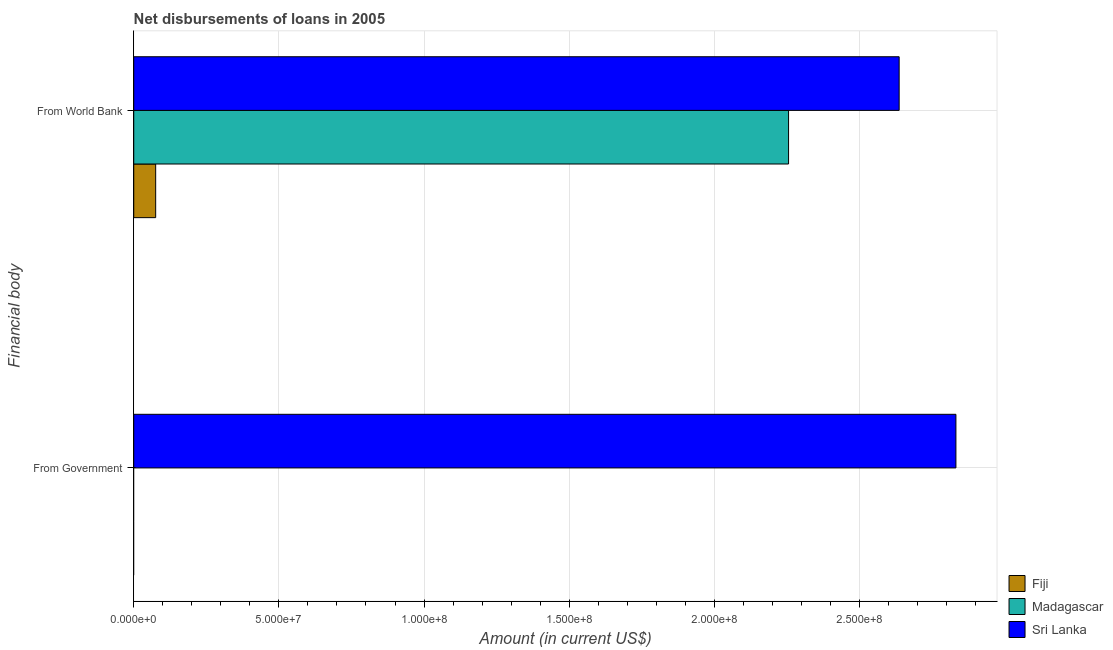Are the number of bars per tick equal to the number of legend labels?
Your response must be concise. No. What is the label of the 1st group of bars from the top?
Offer a terse response. From World Bank. What is the net disbursements of loan from world bank in Fiji?
Make the answer very short. 7.55e+06. Across all countries, what is the maximum net disbursements of loan from government?
Offer a terse response. 2.83e+08. In which country was the net disbursements of loan from government maximum?
Provide a succinct answer. Sri Lanka. What is the total net disbursements of loan from world bank in the graph?
Offer a terse response. 4.97e+08. What is the difference between the net disbursements of loan from world bank in Sri Lanka and that in Fiji?
Give a very brief answer. 2.56e+08. What is the difference between the net disbursements of loan from government in Sri Lanka and the net disbursements of loan from world bank in Fiji?
Offer a terse response. 2.76e+08. What is the average net disbursements of loan from government per country?
Your response must be concise. 9.44e+07. What is the difference between the net disbursements of loan from government and net disbursements of loan from world bank in Sri Lanka?
Your response must be concise. 1.96e+07. In how many countries, is the net disbursements of loan from government greater than 210000000 US$?
Provide a succinct answer. 1. What is the ratio of the net disbursements of loan from world bank in Sri Lanka to that in Fiji?
Offer a very short reply. 34.91. How many bars are there?
Provide a succinct answer. 4. Are all the bars in the graph horizontal?
Provide a short and direct response. Yes. What is the difference between two consecutive major ticks on the X-axis?
Make the answer very short. 5.00e+07. Does the graph contain any zero values?
Keep it short and to the point. Yes. Does the graph contain grids?
Your answer should be very brief. Yes. Where does the legend appear in the graph?
Your answer should be compact. Bottom right. How are the legend labels stacked?
Offer a terse response. Vertical. What is the title of the graph?
Provide a short and direct response. Net disbursements of loans in 2005. Does "Turks and Caicos Islands" appear as one of the legend labels in the graph?
Your response must be concise. No. What is the label or title of the Y-axis?
Your answer should be very brief. Financial body. What is the Amount (in current US$) in Sri Lanka in From Government?
Your answer should be compact. 2.83e+08. What is the Amount (in current US$) of Fiji in From World Bank?
Provide a short and direct response. 7.55e+06. What is the Amount (in current US$) of Madagascar in From World Bank?
Your answer should be very brief. 2.26e+08. What is the Amount (in current US$) of Sri Lanka in From World Bank?
Offer a very short reply. 2.64e+08. Across all Financial body, what is the maximum Amount (in current US$) in Fiji?
Make the answer very short. 7.55e+06. Across all Financial body, what is the maximum Amount (in current US$) of Madagascar?
Ensure brevity in your answer.  2.26e+08. Across all Financial body, what is the maximum Amount (in current US$) of Sri Lanka?
Offer a very short reply. 2.83e+08. Across all Financial body, what is the minimum Amount (in current US$) of Madagascar?
Offer a very short reply. 0. Across all Financial body, what is the minimum Amount (in current US$) of Sri Lanka?
Give a very brief answer. 2.64e+08. What is the total Amount (in current US$) of Fiji in the graph?
Provide a succinct answer. 7.55e+06. What is the total Amount (in current US$) of Madagascar in the graph?
Ensure brevity in your answer.  2.26e+08. What is the total Amount (in current US$) of Sri Lanka in the graph?
Keep it short and to the point. 5.47e+08. What is the difference between the Amount (in current US$) of Sri Lanka in From Government and that in From World Bank?
Make the answer very short. 1.96e+07. What is the average Amount (in current US$) in Fiji per Financial body?
Make the answer very short. 3.78e+06. What is the average Amount (in current US$) in Madagascar per Financial body?
Keep it short and to the point. 1.13e+08. What is the average Amount (in current US$) in Sri Lanka per Financial body?
Provide a succinct answer. 2.73e+08. What is the difference between the Amount (in current US$) of Fiji and Amount (in current US$) of Madagascar in From World Bank?
Offer a terse response. -2.18e+08. What is the difference between the Amount (in current US$) in Fiji and Amount (in current US$) in Sri Lanka in From World Bank?
Ensure brevity in your answer.  -2.56e+08. What is the difference between the Amount (in current US$) in Madagascar and Amount (in current US$) in Sri Lanka in From World Bank?
Ensure brevity in your answer.  -3.81e+07. What is the ratio of the Amount (in current US$) in Sri Lanka in From Government to that in From World Bank?
Your response must be concise. 1.07. What is the difference between the highest and the second highest Amount (in current US$) of Sri Lanka?
Give a very brief answer. 1.96e+07. What is the difference between the highest and the lowest Amount (in current US$) of Fiji?
Offer a terse response. 7.55e+06. What is the difference between the highest and the lowest Amount (in current US$) in Madagascar?
Your response must be concise. 2.26e+08. What is the difference between the highest and the lowest Amount (in current US$) in Sri Lanka?
Your answer should be compact. 1.96e+07. 